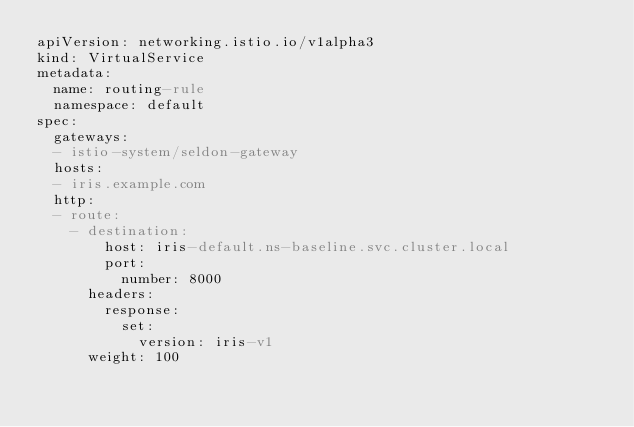<code> <loc_0><loc_0><loc_500><loc_500><_YAML_>apiVersion: networking.istio.io/v1alpha3
kind: VirtualService
metadata:
  name: routing-rule
  namespace: default
spec:
  gateways:
  - istio-system/seldon-gateway
  hosts:
  - iris.example.com
  http:
  - route:
    - destination:
        host: iris-default.ns-baseline.svc.cluster.local
        port:
          number: 8000
      headers:
        response:
          set:
            version: iris-v1
      weight: 100
</code> 